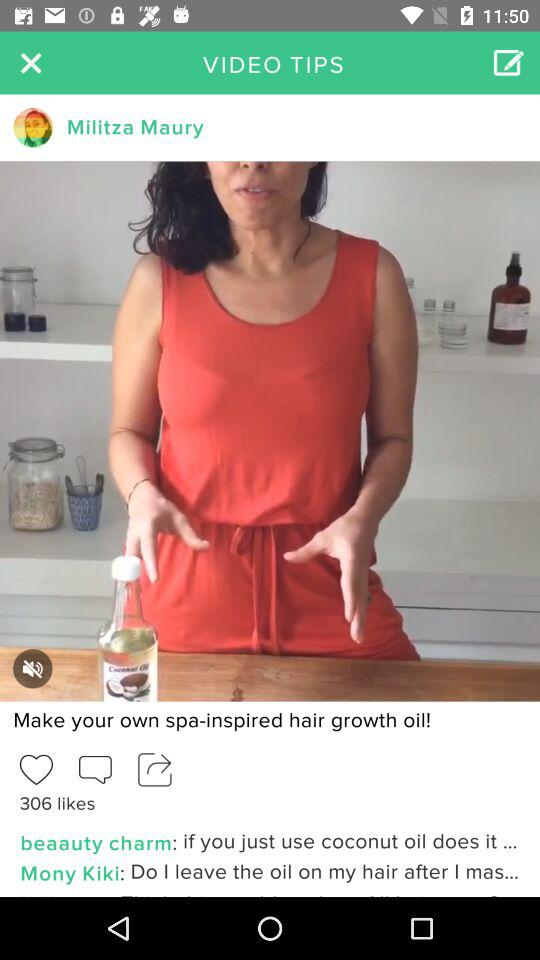Who posted the video? The video was posted by Militza Maury. 